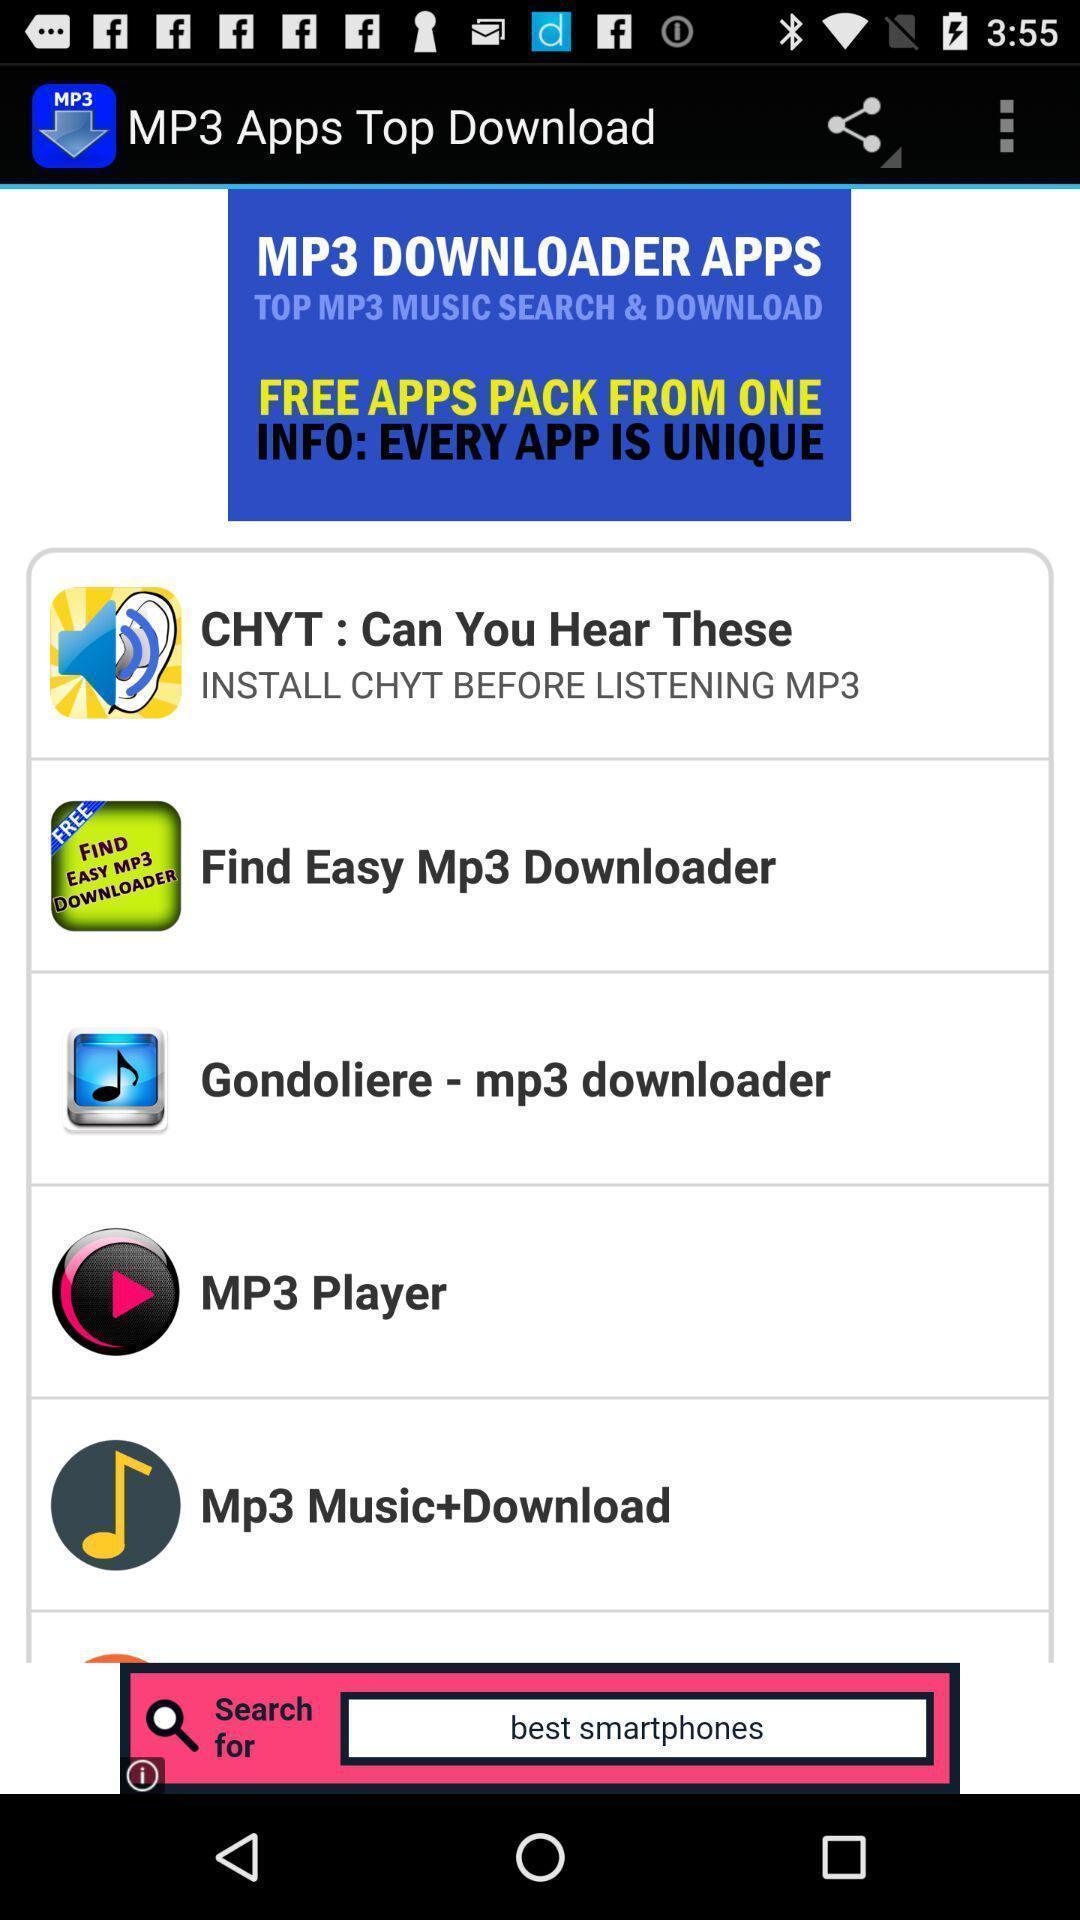What details can you identify in this image? Page showing list of various music player apps. 